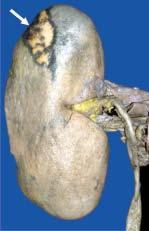s the central area pale while the margin is haemorrhagic?
Answer the question using a single word or phrase. Yes 